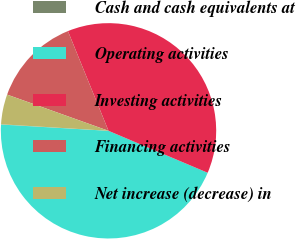Convert chart. <chart><loc_0><loc_0><loc_500><loc_500><pie_chart><fcel>Cash and cash equivalents at<fcel>Operating activities<fcel>Investing activities<fcel>Financing activities<fcel>Net increase (decrease) in<nl><fcel>0.04%<fcel>44.56%<fcel>37.52%<fcel>13.39%<fcel>4.49%<nl></chart> 